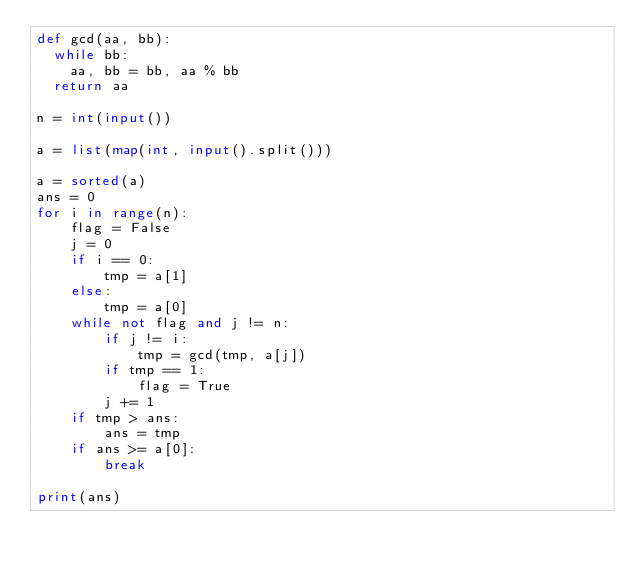<code> <loc_0><loc_0><loc_500><loc_500><_Python_>def gcd(aa, bb):
	while bb:
		aa, bb = bb, aa % bb
	return aa

n = int(input())

a = list(map(int, input().split()))

a = sorted(a)
ans = 0
for i in range(n):
    flag = False
    j = 0
    if i == 0:
        tmp = a[1]
    else:
        tmp = a[0]
    while not flag and j != n:
        if j != i:
            tmp = gcd(tmp, a[j])
        if tmp == 1:
            flag = True
        j += 1
    if tmp > ans:
        ans = tmp
    if ans >= a[0]:
        break

print(ans)</code> 